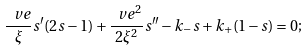<formula> <loc_0><loc_0><loc_500><loc_500>\frac { \ v e } { \xi } s ^ { \prime } ( 2 s - 1 ) + \frac { \ v e ^ { 2 } } { 2 \xi ^ { 2 } } s ^ { \prime \prime } - k _ { - } s + k _ { + } ( 1 - s ) = 0 ;</formula> 